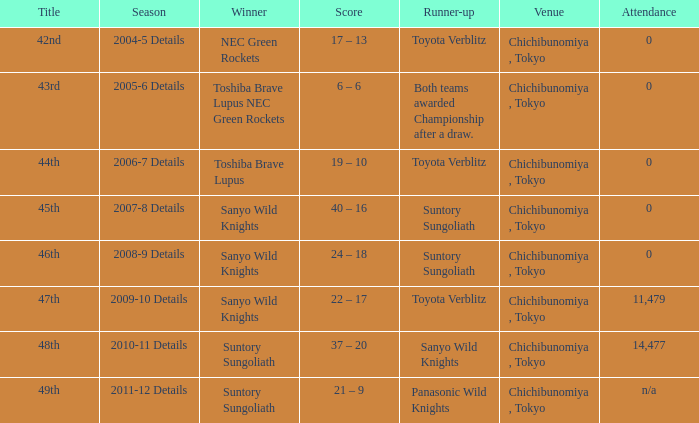Could you parse the entire table? {'header': ['Title', 'Season', 'Winner', 'Score', 'Runner-up', 'Venue', 'Attendance'], 'rows': [['42nd', '2004-5 Details', 'NEC Green Rockets', '17 – 13', 'Toyota Verblitz', 'Chichibunomiya , Tokyo', '0'], ['43rd', '2005-6 Details', 'Toshiba Brave Lupus NEC Green Rockets', '6 – 6', 'Both teams awarded Championship after a draw.', 'Chichibunomiya , Tokyo', '0'], ['44th', '2006-7 Details', 'Toshiba Brave Lupus', '19 – 10', 'Toyota Verblitz', 'Chichibunomiya , Tokyo', '0'], ['45th', '2007-8 Details', 'Sanyo Wild Knights', '40 – 16', 'Suntory Sungoliath', 'Chichibunomiya , Tokyo', '0'], ['46th', '2008-9 Details', 'Sanyo Wild Knights', '24 – 18', 'Suntory Sungoliath', 'Chichibunomiya , Tokyo', '0'], ['47th', '2009-10 Details', 'Sanyo Wild Knights', '22 – 17', 'Toyota Verblitz', 'Chichibunomiya , Tokyo', '11,479'], ['48th', '2010-11 Details', 'Suntory Sungoliath', '37 – 20', 'Sanyo Wild Knights', 'Chichibunomiya , Tokyo', '14,477'], ['49th', '2011-12 Details', 'Suntory Sungoliath', '21 – 9', 'Panasonic Wild Knights', 'Chichibunomiya , Tokyo', 'n/a']]} When sanyo wild knights were the winners and suntory sungoliath were the runner-ups, what was the score? 40 – 16, 24 – 18. 